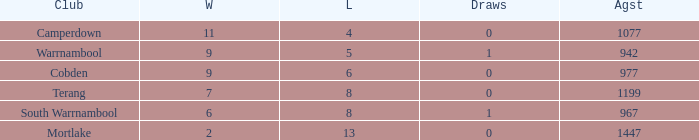How many wins did Cobden have when draws were more than 0? 0.0. 